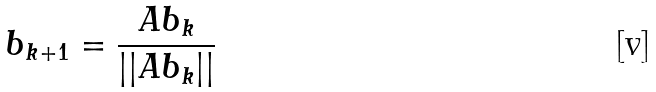<formula> <loc_0><loc_0><loc_500><loc_500>b _ { k + 1 } = \frac { A b _ { k } } { | | A b _ { k } | | }</formula> 